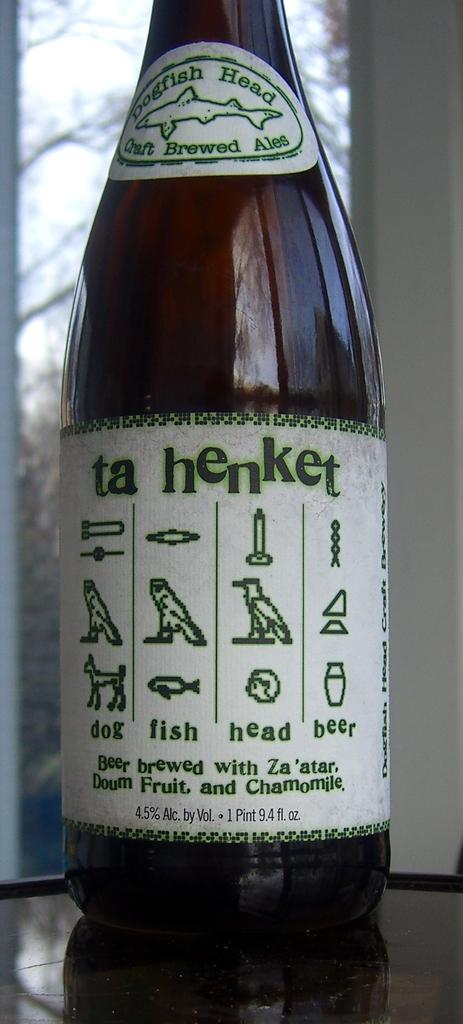What is the volume of the beer?
Keep it short and to the point. 9.4 fl oz. 